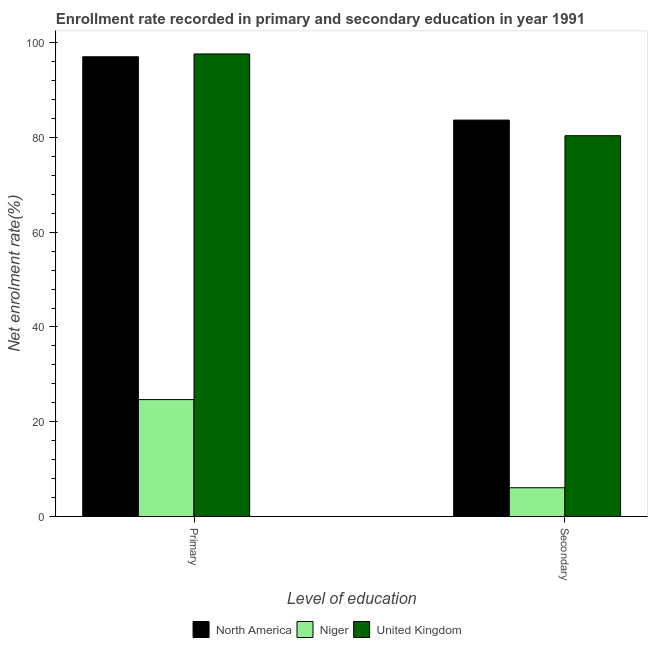Are the number of bars on each tick of the X-axis equal?
Ensure brevity in your answer.  Yes. How many bars are there on the 1st tick from the left?
Give a very brief answer. 3. How many bars are there on the 1st tick from the right?
Your response must be concise. 3. What is the label of the 1st group of bars from the left?
Keep it short and to the point. Primary. What is the enrollment rate in secondary education in United Kingdom?
Make the answer very short. 80.36. Across all countries, what is the maximum enrollment rate in secondary education?
Offer a terse response. 83.66. Across all countries, what is the minimum enrollment rate in primary education?
Offer a very short reply. 24.68. In which country was the enrollment rate in secondary education minimum?
Keep it short and to the point. Niger. What is the total enrollment rate in primary education in the graph?
Ensure brevity in your answer.  219.31. What is the difference between the enrollment rate in secondary education in Niger and that in United Kingdom?
Your answer should be compact. -74.29. What is the difference between the enrollment rate in secondary education in North America and the enrollment rate in primary education in Niger?
Offer a very short reply. 58.99. What is the average enrollment rate in primary education per country?
Ensure brevity in your answer.  73.1. What is the difference between the enrollment rate in secondary education and enrollment rate in primary education in North America?
Your response must be concise. -13.36. In how many countries, is the enrollment rate in secondary education greater than 40 %?
Make the answer very short. 2. What is the ratio of the enrollment rate in secondary education in North America to that in United Kingdom?
Keep it short and to the point. 1.04. Is the enrollment rate in secondary education in Niger less than that in United Kingdom?
Provide a short and direct response. Yes. What does the 3rd bar from the right in Primary represents?
Your answer should be compact. North America. How many bars are there?
Your response must be concise. 6. Are all the bars in the graph horizontal?
Offer a terse response. No. How many countries are there in the graph?
Your answer should be very brief. 3. Does the graph contain any zero values?
Your response must be concise. No. Where does the legend appear in the graph?
Provide a succinct answer. Bottom center. How many legend labels are there?
Offer a terse response. 3. How are the legend labels stacked?
Your answer should be very brief. Horizontal. What is the title of the graph?
Your answer should be very brief. Enrollment rate recorded in primary and secondary education in year 1991. Does "Papua New Guinea" appear as one of the legend labels in the graph?
Your response must be concise. No. What is the label or title of the X-axis?
Offer a terse response. Level of education. What is the label or title of the Y-axis?
Offer a terse response. Net enrolment rate(%). What is the Net enrolment rate(%) in North America in Primary?
Provide a short and direct response. 97.02. What is the Net enrolment rate(%) in Niger in Primary?
Your answer should be very brief. 24.68. What is the Net enrolment rate(%) in United Kingdom in Primary?
Give a very brief answer. 97.62. What is the Net enrolment rate(%) of North America in Secondary?
Keep it short and to the point. 83.66. What is the Net enrolment rate(%) in Niger in Secondary?
Your answer should be compact. 6.07. What is the Net enrolment rate(%) of United Kingdom in Secondary?
Offer a terse response. 80.36. Across all Level of education, what is the maximum Net enrolment rate(%) in North America?
Make the answer very short. 97.02. Across all Level of education, what is the maximum Net enrolment rate(%) in Niger?
Your answer should be very brief. 24.68. Across all Level of education, what is the maximum Net enrolment rate(%) in United Kingdom?
Give a very brief answer. 97.62. Across all Level of education, what is the minimum Net enrolment rate(%) of North America?
Provide a short and direct response. 83.66. Across all Level of education, what is the minimum Net enrolment rate(%) in Niger?
Your answer should be compact. 6.07. Across all Level of education, what is the minimum Net enrolment rate(%) in United Kingdom?
Your response must be concise. 80.36. What is the total Net enrolment rate(%) in North America in the graph?
Offer a terse response. 180.68. What is the total Net enrolment rate(%) in Niger in the graph?
Offer a terse response. 30.75. What is the total Net enrolment rate(%) of United Kingdom in the graph?
Your answer should be compact. 177.98. What is the difference between the Net enrolment rate(%) of North America in Primary and that in Secondary?
Your answer should be compact. 13.36. What is the difference between the Net enrolment rate(%) of Niger in Primary and that in Secondary?
Make the answer very short. 18.6. What is the difference between the Net enrolment rate(%) in United Kingdom in Primary and that in Secondary?
Your answer should be very brief. 17.25. What is the difference between the Net enrolment rate(%) in North America in Primary and the Net enrolment rate(%) in Niger in Secondary?
Make the answer very short. 90.95. What is the difference between the Net enrolment rate(%) in North America in Primary and the Net enrolment rate(%) in United Kingdom in Secondary?
Ensure brevity in your answer.  16.66. What is the difference between the Net enrolment rate(%) of Niger in Primary and the Net enrolment rate(%) of United Kingdom in Secondary?
Provide a succinct answer. -55.69. What is the average Net enrolment rate(%) in North America per Level of education?
Keep it short and to the point. 90.34. What is the average Net enrolment rate(%) of Niger per Level of education?
Provide a succinct answer. 15.37. What is the average Net enrolment rate(%) of United Kingdom per Level of education?
Offer a terse response. 88.99. What is the difference between the Net enrolment rate(%) of North America and Net enrolment rate(%) of Niger in Primary?
Ensure brevity in your answer.  72.35. What is the difference between the Net enrolment rate(%) in North America and Net enrolment rate(%) in United Kingdom in Primary?
Ensure brevity in your answer.  -0.59. What is the difference between the Net enrolment rate(%) in Niger and Net enrolment rate(%) in United Kingdom in Primary?
Your answer should be very brief. -72.94. What is the difference between the Net enrolment rate(%) in North America and Net enrolment rate(%) in Niger in Secondary?
Make the answer very short. 77.59. What is the difference between the Net enrolment rate(%) in North America and Net enrolment rate(%) in United Kingdom in Secondary?
Your answer should be very brief. 3.3. What is the difference between the Net enrolment rate(%) in Niger and Net enrolment rate(%) in United Kingdom in Secondary?
Offer a very short reply. -74.29. What is the ratio of the Net enrolment rate(%) in North America in Primary to that in Secondary?
Offer a terse response. 1.16. What is the ratio of the Net enrolment rate(%) in Niger in Primary to that in Secondary?
Your answer should be very brief. 4.06. What is the ratio of the Net enrolment rate(%) of United Kingdom in Primary to that in Secondary?
Offer a terse response. 1.21. What is the difference between the highest and the second highest Net enrolment rate(%) of North America?
Your answer should be very brief. 13.36. What is the difference between the highest and the second highest Net enrolment rate(%) in Niger?
Make the answer very short. 18.6. What is the difference between the highest and the second highest Net enrolment rate(%) in United Kingdom?
Offer a very short reply. 17.25. What is the difference between the highest and the lowest Net enrolment rate(%) of North America?
Give a very brief answer. 13.36. What is the difference between the highest and the lowest Net enrolment rate(%) in Niger?
Offer a very short reply. 18.6. What is the difference between the highest and the lowest Net enrolment rate(%) in United Kingdom?
Ensure brevity in your answer.  17.25. 